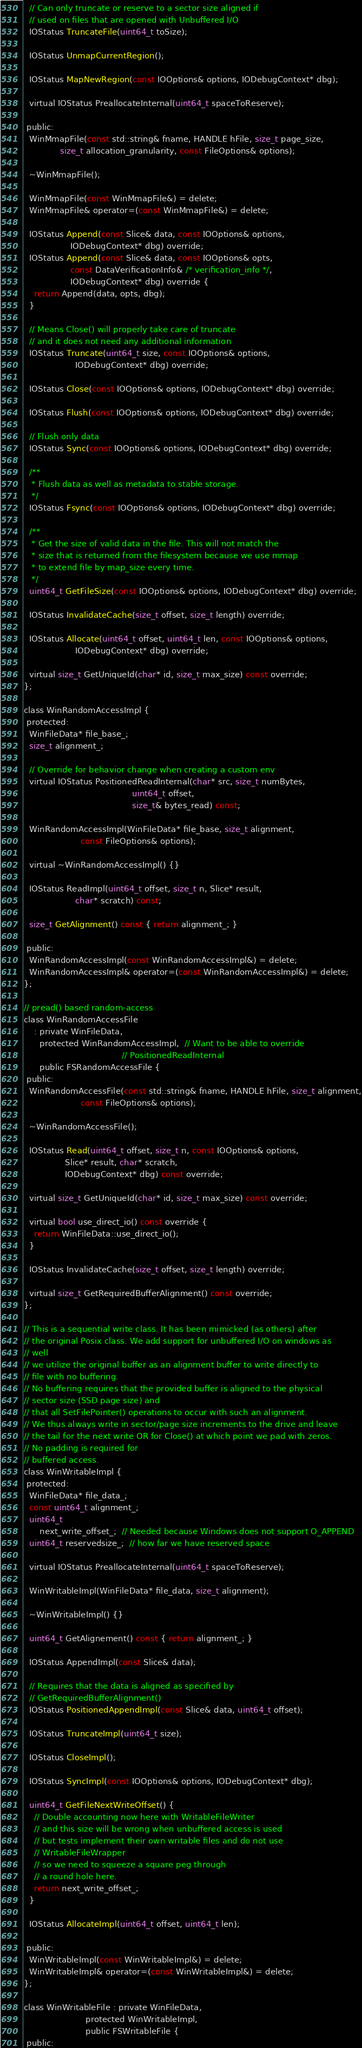Convert code to text. <code><loc_0><loc_0><loc_500><loc_500><_C_>  // Can only truncate or reserve to a sector size aligned if
  // used on files that are opened with Unbuffered I/O
  IOStatus TruncateFile(uint64_t toSize);

  IOStatus UnmapCurrentRegion();

  IOStatus MapNewRegion(const IOOptions& options, IODebugContext* dbg);

  virtual IOStatus PreallocateInternal(uint64_t spaceToReserve);

 public:
  WinMmapFile(const std::string& fname, HANDLE hFile, size_t page_size,
              size_t allocation_granularity, const FileOptions& options);

  ~WinMmapFile();

  WinMmapFile(const WinMmapFile&) = delete;
  WinMmapFile& operator=(const WinMmapFile&) = delete;

  IOStatus Append(const Slice& data, const IOOptions& options,
                  IODebugContext* dbg) override;
  IOStatus Append(const Slice& data, const IOOptions& opts,
                  const DataVerificationInfo& /* verification_info */,
                  IODebugContext* dbg) override {
    return Append(data, opts, dbg);
  }

  // Means Close() will properly take care of truncate
  // and it does not need any additional information
  IOStatus Truncate(uint64_t size, const IOOptions& options,
                    IODebugContext* dbg) override;

  IOStatus Close(const IOOptions& options, IODebugContext* dbg) override;

  IOStatus Flush(const IOOptions& options, IODebugContext* dbg) override;

  // Flush only data
  IOStatus Sync(const IOOptions& options, IODebugContext* dbg) override;

  /**
   * Flush data as well as metadata to stable storage.
   */
  IOStatus Fsync(const IOOptions& options, IODebugContext* dbg) override;

  /**
   * Get the size of valid data in the file. This will not match the
   * size that is returned from the filesystem because we use mmap
   * to extend file by map_size every time.
   */
  uint64_t GetFileSize(const IOOptions& options, IODebugContext* dbg) override;

  IOStatus InvalidateCache(size_t offset, size_t length) override;

  IOStatus Allocate(uint64_t offset, uint64_t len, const IOOptions& options,
                    IODebugContext* dbg) override;

  virtual size_t GetUniqueId(char* id, size_t max_size) const override;
};

class WinRandomAccessImpl {
 protected:
  WinFileData* file_base_;
  size_t alignment_;

  // Override for behavior change when creating a custom env
  virtual IOStatus PositionedReadInternal(char* src, size_t numBytes,
                                          uint64_t offset,
                                          size_t& bytes_read) const;

  WinRandomAccessImpl(WinFileData* file_base, size_t alignment,
                      const FileOptions& options);

  virtual ~WinRandomAccessImpl() {}

  IOStatus ReadImpl(uint64_t offset, size_t n, Slice* result,
                    char* scratch) const;

  size_t GetAlignment() const { return alignment_; }

 public:
  WinRandomAccessImpl(const WinRandomAccessImpl&) = delete;
  WinRandomAccessImpl& operator=(const WinRandomAccessImpl&) = delete;
};

// pread() based random-access
class WinRandomAccessFile
    : private WinFileData,
      protected WinRandomAccessImpl,  // Want to be able to override
                                      // PositionedReadInternal
      public FSRandomAccessFile {
 public:
  WinRandomAccessFile(const std::string& fname, HANDLE hFile, size_t alignment,
                      const FileOptions& options);

  ~WinRandomAccessFile();

  IOStatus Read(uint64_t offset, size_t n, const IOOptions& options,
                Slice* result, char* scratch,
                IODebugContext* dbg) const override;

  virtual size_t GetUniqueId(char* id, size_t max_size) const override;

  virtual bool use_direct_io() const override {
    return WinFileData::use_direct_io();
  }

  IOStatus InvalidateCache(size_t offset, size_t length) override;

  virtual size_t GetRequiredBufferAlignment() const override;
};

// This is a sequential write class. It has been mimicked (as others) after
// the original Posix class. We add support for unbuffered I/O on windows as
// well
// we utilize the original buffer as an alignment buffer to write directly to
// file with no buffering.
// No buffering requires that the provided buffer is aligned to the physical
// sector size (SSD page size) and
// that all SetFilePointer() operations to occur with such an alignment.
// We thus always write in sector/page size increments to the drive and leave
// the tail for the next write OR for Close() at which point we pad with zeros.
// No padding is required for
// buffered access.
class WinWritableImpl {
 protected:
  WinFileData* file_data_;
  const uint64_t alignment_;
  uint64_t
      next_write_offset_;  // Needed because Windows does not support O_APPEND
  uint64_t reservedsize_;  // how far we have reserved space

  virtual IOStatus PreallocateInternal(uint64_t spaceToReserve);

  WinWritableImpl(WinFileData* file_data, size_t alignment);

  ~WinWritableImpl() {}

  uint64_t GetAlignement() const { return alignment_; }

  IOStatus AppendImpl(const Slice& data);

  // Requires that the data is aligned as specified by
  // GetRequiredBufferAlignment()
  IOStatus PositionedAppendImpl(const Slice& data, uint64_t offset);

  IOStatus TruncateImpl(uint64_t size);

  IOStatus CloseImpl();

  IOStatus SyncImpl(const IOOptions& options, IODebugContext* dbg);

  uint64_t GetFileNextWriteOffset() {
    // Double accounting now here with WritableFileWriter
    // and this size will be wrong when unbuffered access is used
    // but tests implement their own writable files and do not use
    // WritableFileWrapper
    // so we need to squeeze a square peg through
    // a round hole here.
    return next_write_offset_;
  }

  IOStatus AllocateImpl(uint64_t offset, uint64_t len);

 public:
  WinWritableImpl(const WinWritableImpl&) = delete;
  WinWritableImpl& operator=(const WinWritableImpl&) = delete;
};

class WinWritableFile : private WinFileData,
                        protected WinWritableImpl,
                        public FSWritableFile {
 public:</code> 